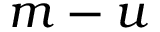Convert formula to latex. <formula><loc_0><loc_0><loc_500><loc_500>m - u</formula> 